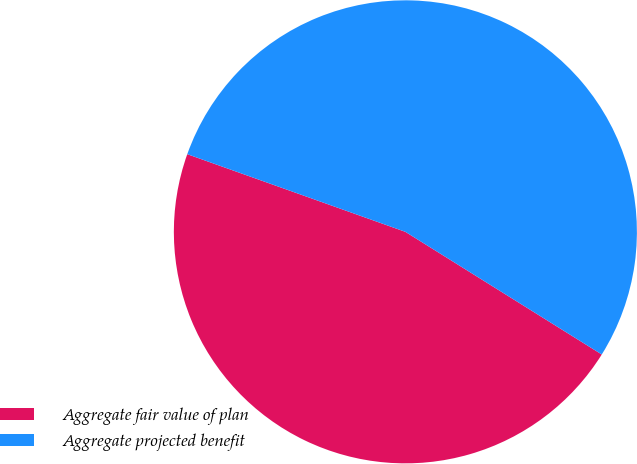<chart> <loc_0><loc_0><loc_500><loc_500><pie_chart><fcel>Aggregate fair value of plan<fcel>Aggregate projected benefit<nl><fcel>46.56%<fcel>53.44%<nl></chart> 